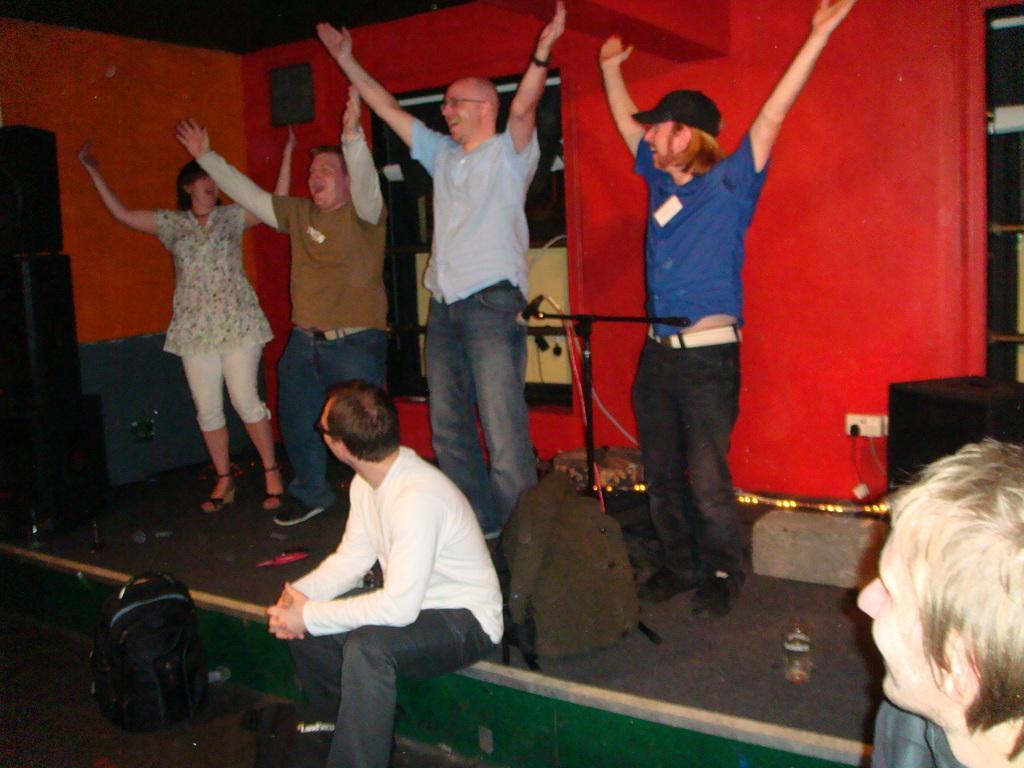Could you give a brief overview of what you see in this image? In this image, I can see four people standing and raising their hands. Here is a person sitting on the stage. This looks like a mike stand and a bag. On the left side of the image, I can see the black color object. This is the wall. At the bottom right side of the image, I can see a person's head. Here is another bag, which is on the floor. 